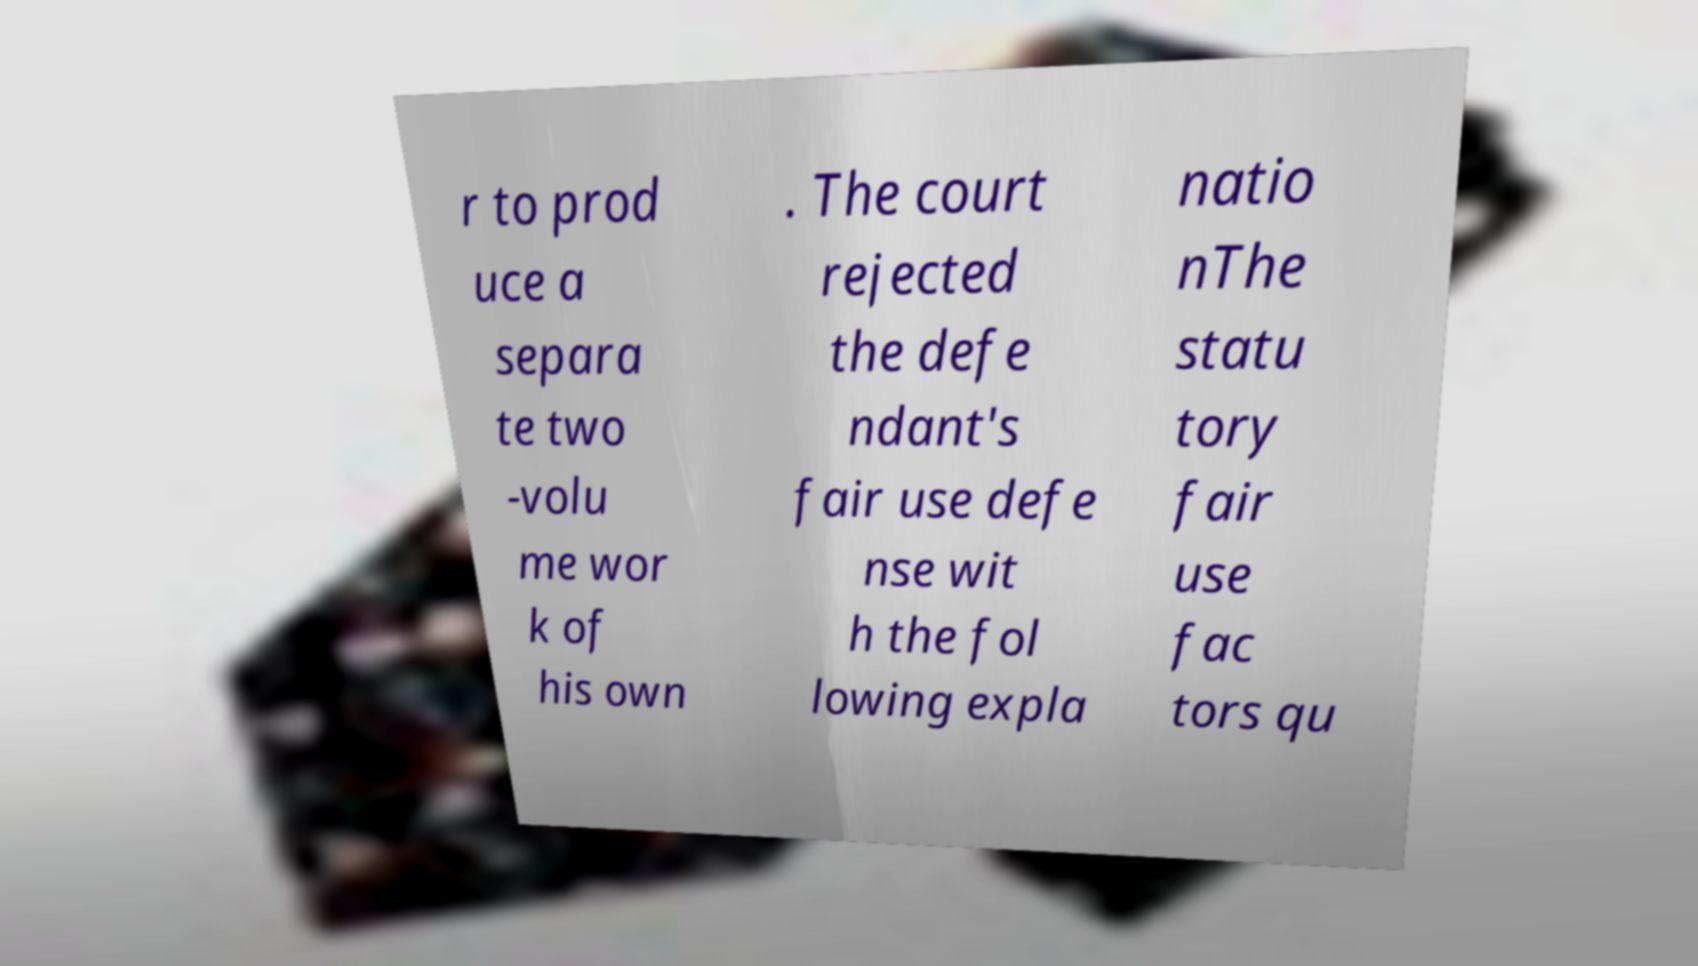Could you assist in decoding the text presented in this image and type it out clearly? r to prod uce a separa te two -volu me wor k of his own . The court rejected the defe ndant's fair use defe nse wit h the fol lowing expla natio nThe statu tory fair use fac tors qu 